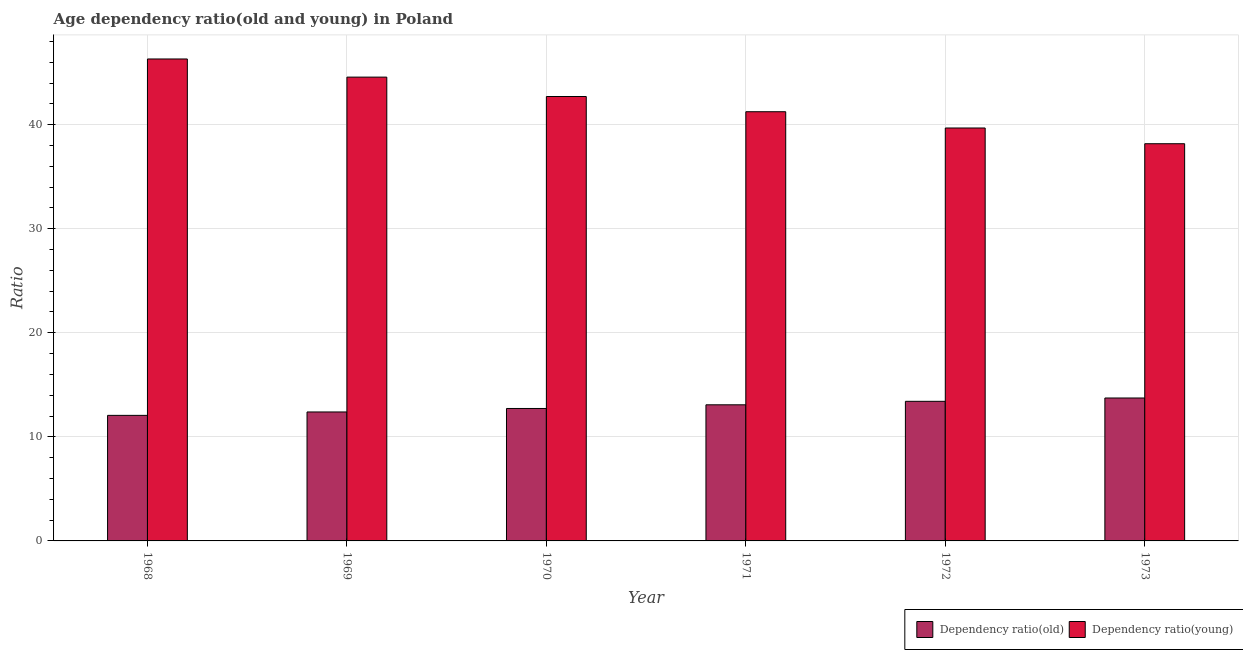Are the number of bars per tick equal to the number of legend labels?
Keep it short and to the point. Yes. How many bars are there on the 5th tick from the left?
Keep it short and to the point. 2. In how many cases, is the number of bars for a given year not equal to the number of legend labels?
Offer a very short reply. 0. What is the age dependency ratio(old) in 1969?
Give a very brief answer. 12.39. Across all years, what is the maximum age dependency ratio(old)?
Your answer should be compact. 13.73. Across all years, what is the minimum age dependency ratio(young)?
Give a very brief answer. 38.17. In which year was the age dependency ratio(young) maximum?
Provide a short and direct response. 1968. What is the total age dependency ratio(young) in the graph?
Give a very brief answer. 252.67. What is the difference between the age dependency ratio(old) in 1968 and that in 1971?
Your answer should be compact. -1.01. What is the difference between the age dependency ratio(young) in 1972 and the age dependency ratio(old) in 1970?
Your answer should be compact. -3.03. What is the average age dependency ratio(young) per year?
Provide a succinct answer. 42.11. What is the ratio of the age dependency ratio(old) in 1968 to that in 1973?
Offer a terse response. 0.88. Is the age dependency ratio(old) in 1968 less than that in 1969?
Provide a short and direct response. Yes. What is the difference between the highest and the second highest age dependency ratio(old)?
Make the answer very short. 0.32. What is the difference between the highest and the lowest age dependency ratio(young)?
Give a very brief answer. 8.14. Is the sum of the age dependency ratio(old) in 1968 and 1970 greater than the maximum age dependency ratio(young) across all years?
Your answer should be very brief. Yes. What does the 1st bar from the left in 1968 represents?
Your response must be concise. Dependency ratio(old). What does the 2nd bar from the right in 1970 represents?
Keep it short and to the point. Dependency ratio(old). How many bars are there?
Your answer should be very brief. 12. How many years are there in the graph?
Provide a short and direct response. 6. Are the values on the major ticks of Y-axis written in scientific E-notation?
Keep it short and to the point. No. What is the title of the graph?
Keep it short and to the point. Age dependency ratio(old and young) in Poland. Does "Methane" appear as one of the legend labels in the graph?
Your answer should be very brief. No. What is the label or title of the Y-axis?
Give a very brief answer. Ratio. What is the Ratio of Dependency ratio(old) in 1968?
Your response must be concise. 12.06. What is the Ratio in Dependency ratio(young) in 1968?
Give a very brief answer. 46.31. What is the Ratio in Dependency ratio(old) in 1969?
Your response must be concise. 12.39. What is the Ratio of Dependency ratio(young) in 1969?
Give a very brief answer. 44.57. What is the Ratio in Dependency ratio(old) in 1970?
Your answer should be compact. 12.73. What is the Ratio of Dependency ratio(young) in 1970?
Offer a very short reply. 42.71. What is the Ratio in Dependency ratio(old) in 1971?
Ensure brevity in your answer.  13.08. What is the Ratio of Dependency ratio(young) in 1971?
Offer a very short reply. 41.24. What is the Ratio of Dependency ratio(old) in 1972?
Give a very brief answer. 13.41. What is the Ratio of Dependency ratio(young) in 1972?
Your answer should be compact. 39.68. What is the Ratio of Dependency ratio(old) in 1973?
Offer a terse response. 13.73. What is the Ratio of Dependency ratio(young) in 1973?
Ensure brevity in your answer.  38.17. Across all years, what is the maximum Ratio in Dependency ratio(old)?
Provide a succinct answer. 13.73. Across all years, what is the maximum Ratio in Dependency ratio(young)?
Provide a succinct answer. 46.31. Across all years, what is the minimum Ratio of Dependency ratio(old)?
Ensure brevity in your answer.  12.06. Across all years, what is the minimum Ratio in Dependency ratio(young)?
Give a very brief answer. 38.17. What is the total Ratio in Dependency ratio(old) in the graph?
Ensure brevity in your answer.  77.41. What is the total Ratio in Dependency ratio(young) in the graph?
Provide a short and direct response. 252.67. What is the difference between the Ratio in Dependency ratio(old) in 1968 and that in 1969?
Your answer should be very brief. -0.33. What is the difference between the Ratio in Dependency ratio(young) in 1968 and that in 1969?
Your answer should be very brief. 1.74. What is the difference between the Ratio of Dependency ratio(old) in 1968 and that in 1970?
Your answer should be very brief. -0.66. What is the difference between the Ratio in Dependency ratio(young) in 1968 and that in 1970?
Provide a short and direct response. 3.61. What is the difference between the Ratio of Dependency ratio(old) in 1968 and that in 1971?
Your answer should be compact. -1.01. What is the difference between the Ratio of Dependency ratio(young) in 1968 and that in 1971?
Your answer should be very brief. 5.07. What is the difference between the Ratio in Dependency ratio(old) in 1968 and that in 1972?
Give a very brief answer. -1.35. What is the difference between the Ratio in Dependency ratio(young) in 1968 and that in 1972?
Provide a short and direct response. 6.63. What is the difference between the Ratio in Dependency ratio(old) in 1968 and that in 1973?
Ensure brevity in your answer.  -1.67. What is the difference between the Ratio of Dependency ratio(young) in 1968 and that in 1973?
Give a very brief answer. 8.14. What is the difference between the Ratio in Dependency ratio(old) in 1969 and that in 1970?
Your answer should be compact. -0.33. What is the difference between the Ratio of Dependency ratio(young) in 1969 and that in 1970?
Provide a short and direct response. 1.86. What is the difference between the Ratio of Dependency ratio(old) in 1969 and that in 1971?
Your answer should be compact. -0.69. What is the difference between the Ratio of Dependency ratio(young) in 1969 and that in 1971?
Provide a short and direct response. 3.33. What is the difference between the Ratio in Dependency ratio(old) in 1969 and that in 1972?
Your answer should be compact. -1.02. What is the difference between the Ratio of Dependency ratio(young) in 1969 and that in 1972?
Offer a very short reply. 4.89. What is the difference between the Ratio in Dependency ratio(old) in 1969 and that in 1973?
Your answer should be very brief. -1.34. What is the difference between the Ratio in Dependency ratio(young) in 1969 and that in 1973?
Offer a terse response. 6.4. What is the difference between the Ratio in Dependency ratio(old) in 1970 and that in 1971?
Give a very brief answer. -0.35. What is the difference between the Ratio in Dependency ratio(young) in 1970 and that in 1971?
Give a very brief answer. 1.46. What is the difference between the Ratio in Dependency ratio(old) in 1970 and that in 1972?
Keep it short and to the point. -0.69. What is the difference between the Ratio of Dependency ratio(young) in 1970 and that in 1972?
Make the answer very short. 3.03. What is the difference between the Ratio of Dependency ratio(old) in 1970 and that in 1973?
Keep it short and to the point. -1.01. What is the difference between the Ratio in Dependency ratio(young) in 1970 and that in 1973?
Your answer should be very brief. 4.54. What is the difference between the Ratio in Dependency ratio(old) in 1971 and that in 1972?
Provide a short and direct response. -0.34. What is the difference between the Ratio in Dependency ratio(young) in 1971 and that in 1972?
Provide a short and direct response. 1.56. What is the difference between the Ratio of Dependency ratio(old) in 1971 and that in 1973?
Provide a short and direct response. -0.65. What is the difference between the Ratio in Dependency ratio(young) in 1971 and that in 1973?
Give a very brief answer. 3.07. What is the difference between the Ratio of Dependency ratio(old) in 1972 and that in 1973?
Provide a short and direct response. -0.32. What is the difference between the Ratio in Dependency ratio(young) in 1972 and that in 1973?
Provide a short and direct response. 1.51. What is the difference between the Ratio in Dependency ratio(old) in 1968 and the Ratio in Dependency ratio(young) in 1969?
Give a very brief answer. -32.5. What is the difference between the Ratio in Dependency ratio(old) in 1968 and the Ratio in Dependency ratio(young) in 1970?
Offer a very short reply. -30.64. What is the difference between the Ratio in Dependency ratio(old) in 1968 and the Ratio in Dependency ratio(young) in 1971?
Make the answer very short. -29.18. What is the difference between the Ratio of Dependency ratio(old) in 1968 and the Ratio of Dependency ratio(young) in 1972?
Your answer should be very brief. -27.61. What is the difference between the Ratio in Dependency ratio(old) in 1968 and the Ratio in Dependency ratio(young) in 1973?
Your response must be concise. -26.1. What is the difference between the Ratio in Dependency ratio(old) in 1969 and the Ratio in Dependency ratio(young) in 1970?
Provide a short and direct response. -30.31. What is the difference between the Ratio of Dependency ratio(old) in 1969 and the Ratio of Dependency ratio(young) in 1971?
Offer a very short reply. -28.85. What is the difference between the Ratio in Dependency ratio(old) in 1969 and the Ratio in Dependency ratio(young) in 1972?
Keep it short and to the point. -27.29. What is the difference between the Ratio in Dependency ratio(old) in 1969 and the Ratio in Dependency ratio(young) in 1973?
Your response must be concise. -25.78. What is the difference between the Ratio of Dependency ratio(old) in 1970 and the Ratio of Dependency ratio(young) in 1971?
Offer a terse response. -28.52. What is the difference between the Ratio of Dependency ratio(old) in 1970 and the Ratio of Dependency ratio(young) in 1972?
Your response must be concise. -26.95. What is the difference between the Ratio of Dependency ratio(old) in 1970 and the Ratio of Dependency ratio(young) in 1973?
Provide a succinct answer. -25.44. What is the difference between the Ratio of Dependency ratio(old) in 1971 and the Ratio of Dependency ratio(young) in 1972?
Give a very brief answer. -26.6. What is the difference between the Ratio in Dependency ratio(old) in 1971 and the Ratio in Dependency ratio(young) in 1973?
Give a very brief answer. -25.09. What is the difference between the Ratio of Dependency ratio(old) in 1972 and the Ratio of Dependency ratio(young) in 1973?
Offer a very short reply. -24.75. What is the average Ratio in Dependency ratio(old) per year?
Offer a very short reply. 12.9. What is the average Ratio of Dependency ratio(young) per year?
Keep it short and to the point. 42.11. In the year 1968, what is the difference between the Ratio of Dependency ratio(old) and Ratio of Dependency ratio(young)?
Keep it short and to the point. -34.25. In the year 1969, what is the difference between the Ratio in Dependency ratio(old) and Ratio in Dependency ratio(young)?
Your answer should be compact. -32.18. In the year 1970, what is the difference between the Ratio of Dependency ratio(old) and Ratio of Dependency ratio(young)?
Keep it short and to the point. -29.98. In the year 1971, what is the difference between the Ratio of Dependency ratio(old) and Ratio of Dependency ratio(young)?
Offer a terse response. -28.16. In the year 1972, what is the difference between the Ratio in Dependency ratio(old) and Ratio in Dependency ratio(young)?
Your answer should be compact. -26.26. In the year 1973, what is the difference between the Ratio in Dependency ratio(old) and Ratio in Dependency ratio(young)?
Your answer should be very brief. -24.43. What is the ratio of the Ratio in Dependency ratio(old) in 1968 to that in 1969?
Keep it short and to the point. 0.97. What is the ratio of the Ratio in Dependency ratio(young) in 1968 to that in 1969?
Provide a short and direct response. 1.04. What is the ratio of the Ratio of Dependency ratio(old) in 1968 to that in 1970?
Your answer should be very brief. 0.95. What is the ratio of the Ratio in Dependency ratio(young) in 1968 to that in 1970?
Give a very brief answer. 1.08. What is the ratio of the Ratio of Dependency ratio(old) in 1968 to that in 1971?
Keep it short and to the point. 0.92. What is the ratio of the Ratio of Dependency ratio(young) in 1968 to that in 1971?
Provide a short and direct response. 1.12. What is the ratio of the Ratio of Dependency ratio(old) in 1968 to that in 1972?
Your answer should be compact. 0.9. What is the ratio of the Ratio of Dependency ratio(young) in 1968 to that in 1972?
Make the answer very short. 1.17. What is the ratio of the Ratio in Dependency ratio(old) in 1968 to that in 1973?
Offer a terse response. 0.88. What is the ratio of the Ratio in Dependency ratio(young) in 1968 to that in 1973?
Provide a succinct answer. 1.21. What is the ratio of the Ratio in Dependency ratio(old) in 1969 to that in 1970?
Your answer should be very brief. 0.97. What is the ratio of the Ratio in Dependency ratio(young) in 1969 to that in 1970?
Make the answer very short. 1.04. What is the ratio of the Ratio of Dependency ratio(young) in 1969 to that in 1971?
Offer a very short reply. 1.08. What is the ratio of the Ratio of Dependency ratio(old) in 1969 to that in 1972?
Ensure brevity in your answer.  0.92. What is the ratio of the Ratio in Dependency ratio(young) in 1969 to that in 1972?
Offer a very short reply. 1.12. What is the ratio of the Ratio in Dependency ratio(old) in 1969 to that in 1973?
Make the answer very short. 0.9. What is the ratio of the Ratio in Dependency ratio(young) in 1969 to that in 1973?
Give a very brief answer. 1.17. What is the ratio of the Ratio in Dependency ratio(old) in 1970 to that in 1971?
Ensure brevity in your answer.  0.97. What is the ratio of the Ratio of Dependency ratio(young) in 1970 to that in 1971?
Provide a succinct answer. 1.04. What is the ratio of the Ratio in Dependency ratio(old) in 1970 to that in 1972?
Offer a very short reply. 0.95. What is the ratio of the Ratio in Dependency ratio(young) in 1970 to that in 1972?
Provide a succinct answer. 1.08. What is the ratio of the Ratio in Dependency ratio(old) in 1970 to that in 1973?
Give a very brief answer. 0.93. What is the ratio of the Ratio in Dependency ratio(young) in 1970 to that in 1973?
Provide a short and direct response. 1.12. What is the ratio of the Ratio of Dependency ratio(old) in 1971 to that in 1972?
Provide a short and direct response. 0.97. What is the ratio of the Ratio of Dependency ratio(young) in 1971 to that in 1972?
Your answer should be compact. 1.04. What is the ratio of the Ratio of Dependency ratio(old) in 1971 to that in 1973?
Offer a very short reply. 0.95. What is the ratio of the Ratio in Dependency ratio(young) in 1971 to that in 1973?
Provide a short and direct response. 1.08. What is the ratio of the Ratio in Dependency ratio(old) in 1972 to that in 1973?
Your response must be concise. 0.98. What is the ratio of the Ratio of Dependency ratio(young) in 1972 to that in 1973?
Give a very brief answer. 1.04. What is the difference between the highest and the second highest Ratio of Dependency ratio(old)?
Ensure brevity in your answer.  0.32. What is the difference between the highest and the second highest Ratio of Dependency ratio(young)?
Your answer should be very brief. 1.74. What is the difference between the highest and the lowest Ratio of Dependency ratio(old)?
Offer a terse response. 1.67. What is the difference between the highest and the lowest Ratio of Dependency ratio(young)?
Offer a terse response. 8.14. 